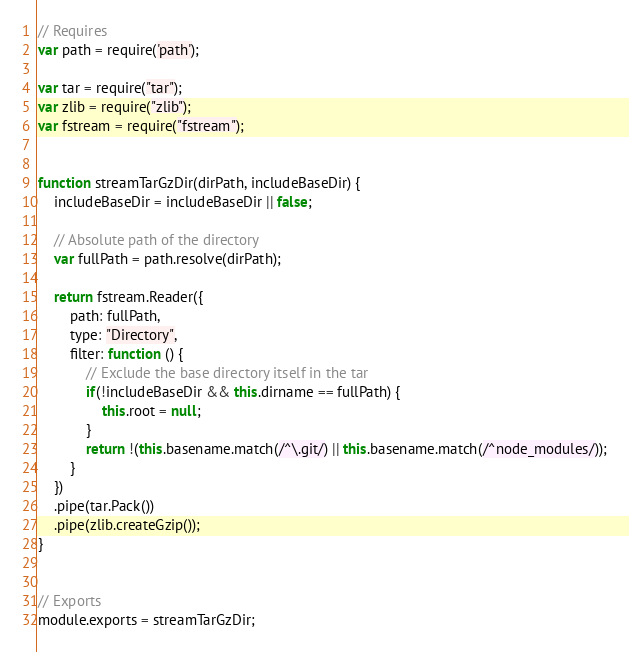Convert code to text. <code><loc_0><loc_0><loc_500><loc_500><_JavaScript_>// Requires
var path = require('path');

var tar = require("tar");
var zlib = require("zlib");
var fstream = require("fstream");


function streamTarGzDir(dirPath, includeBaseDir) {
    includeBaseDir = includeBaseDir || false;

    // Absolute path of the directory
    var fullPath = path.resolve(dirPath);

    return fstream.Reader({
        path: fullPath,
        type: "Directory",
        filter: function () {
            // Exclude the base directory itself in the tar
            if(!includeBaseDir && this.dirname == fullPath) {
                this.root = null;
            }
            return !(this.basename.match(/^\.git/) || this.basename.match(/^node_modules/));
        }
    })
    .pipe(tar.Pack())
    .pipe(zlib.createGzip());
}


// Exports
module.exports = streamTarGzDir;
</code> 